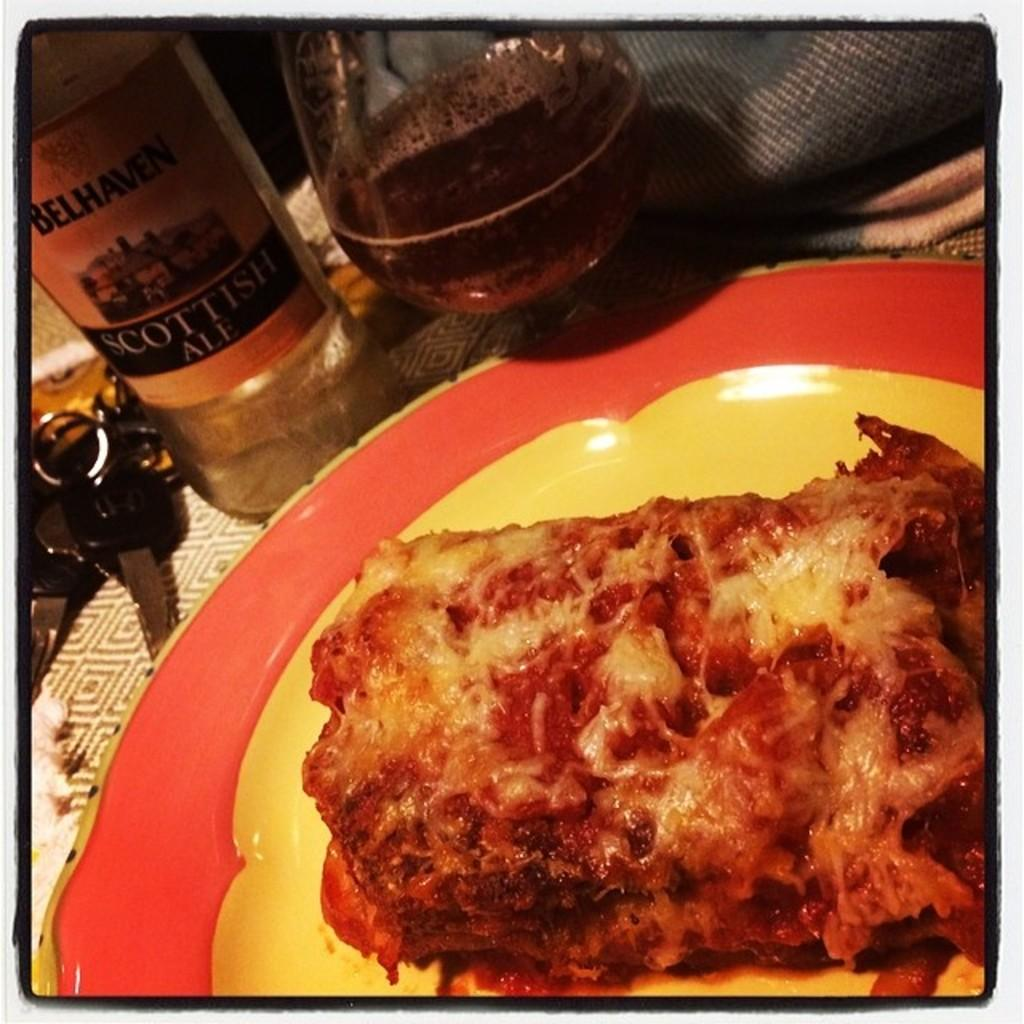<image>
Create a compact narrative representing the image presented. A slice of lasagna with a bottle of Scottish Ale next to it. 